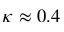<formula> <loc_0><loc_0><loc_500><loc_500>\kappa \approx 0 . 4</formula> 